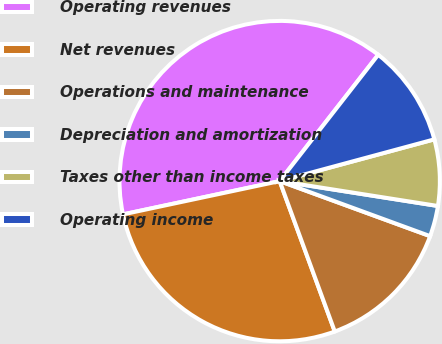Convert chart. <chart><loc_0><loc_0><loc_500><loc_500><pie_chart><fcel>Operating revenues<fcel>Net revenues<fcel>Operations and maintenance<fcel>Depreciation and amortization<fcel>Taxes other than income taxes<fcel>Operating income<nl><fcel>38.88%<fcel>27.26%<fcel>13.83%<fcel>3.1%<fcel>6.68%<fcel>10.26%<nl></chart> 